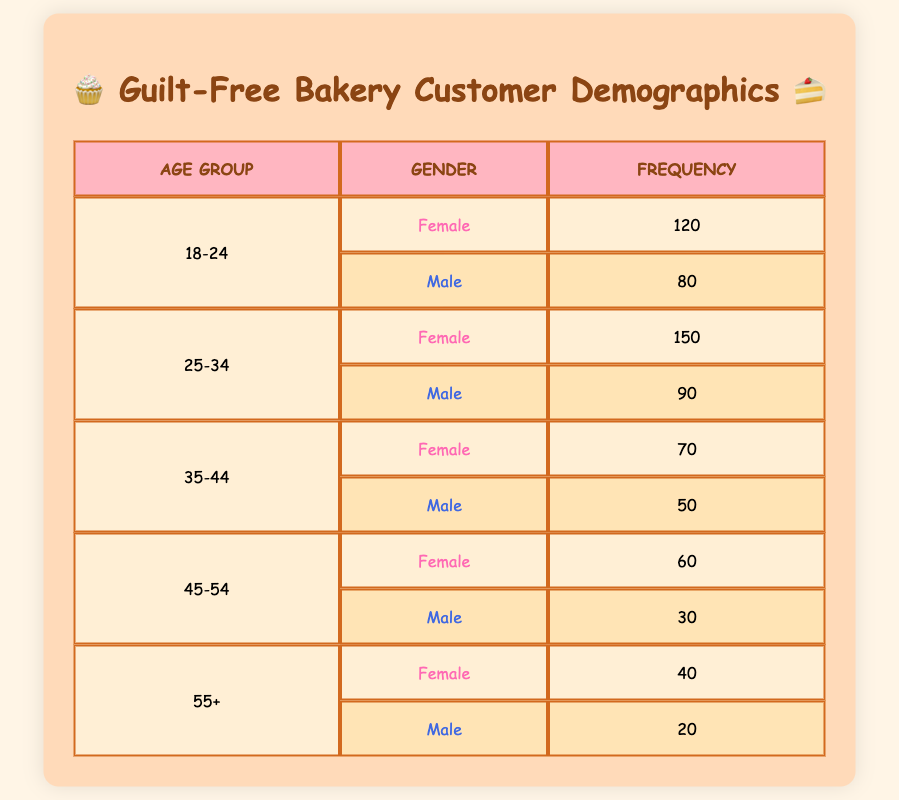What is the frequency of female customers in the age group 25-34? In the table, under the age group 25-34, the frequency for female customers is specifically listed as 150.
Answer: 150 What is the total frequency of male customers across all age groups? To find the total frequency of male customers, we add the frequencies for all male age groups: 80 (18-24) + 90 (25-34) + 50 (35-44) + 30 (45-54) + 20 (55+) = 270.
Answer: 270 Are there more female customers than male customers in the age group 35-44? The frequency of female customers in this age group is 70, while for male it is 50. Since 70 is greater than 50, the answer is yes.
Answer: Yes What age group has the highest total frequency? To determine the age group with the highest total frequency, we need to calculate the total for each age group: 18-24 (120 + 80 = 200), 25-34 (150 + 90 = 240), 35-44 (70 + 50 = 120), 45-54 (60 + 30 = 90), and 55+ (40 + 20 = 60). The highest total frequency is 240 in the age group 25-34.
Answer: 25-34 What percentage of the customers in the age group 45-54 are female? In the age group 45-54, the frequency of female customers is 60, and the total frequency for this age group is 60 (female) + 30 (male) = 90. The percentage is calculated as (60 / 90) * 100 = 66.67%.
Answer: 66.67% How many more female customers than male customers are there in the age group 18-24? The frequency of female customers in the age group 18-24 is 120, and for males, it is 80. The difference is calculated as 120 - 80 = 40.
Answer: 40 What is the average frequency of male customers across all age groups? To find the average, we first sum the frequencies of male customers: 80 + 90 + 50 + 30 + 20 = 270. There are 5 age groups, so the average frequency is 270 / 5 = 54.
Answer: 54 Is the frequency of female customers in the age group 55+ greater than 40? The frequency of female customers in the age group 55+ is 40, so the comparison indicates that it is not greater. Thus, the answer is no.
Answer: No What is the highest frequency found in the entire table? The highest frequency in the table can be identified by comparing all frequencies listed. The highest number is 150 in the age group 25-34 for female customers.
Answer: 150 